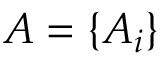<formula> <loc_0><loc_0><loc_500><loc_500>A = \{ A _ { i } \}</formula> 